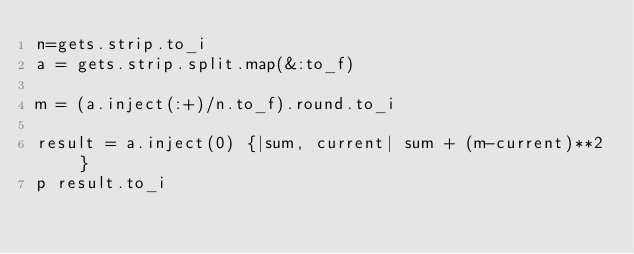Convert code to text. <code><loc_0><loc_0><loc_500><loc_500><_Ruby_>n=gets.strip.to_i
a = gets.strip.split.map(&:to_f)

m = (a.inject(:+)/n.to_f).round.to_i

result = a.inject(0) {|sum, current| sum + (m-current)**2 }
p result.to_i
</code> 